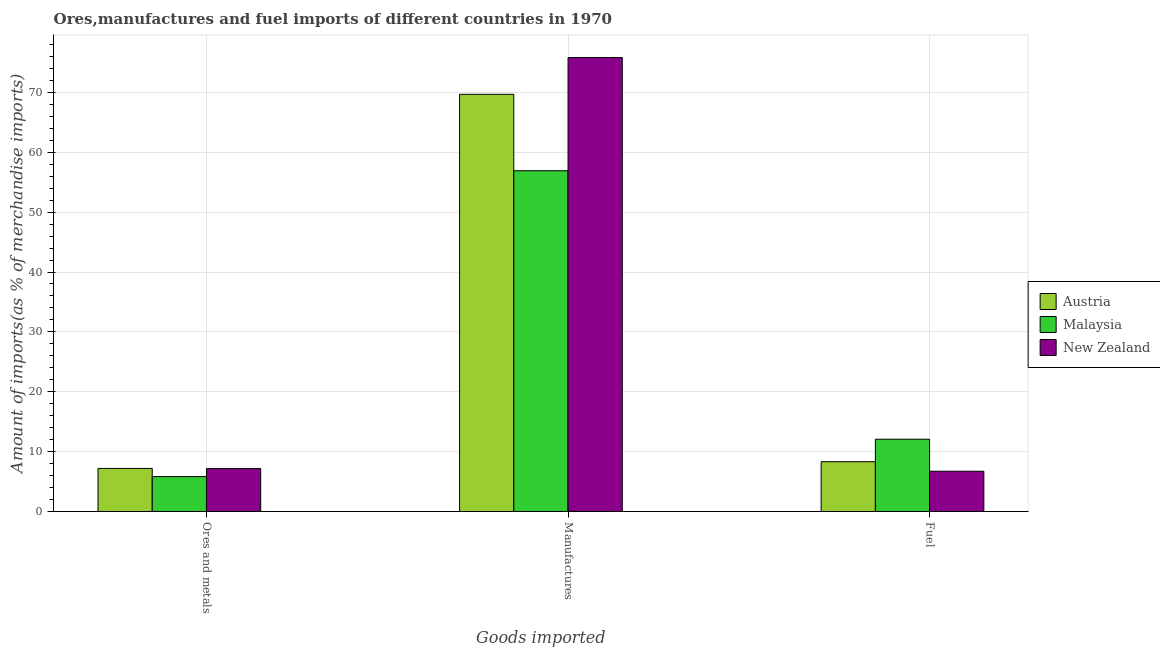How many groups of bars are there?
Give a very brief answer. 3. Are the number of bars per tick equal to the number of legend labels?
Your answer should be very brief. Yes. Are the number of bars on each tick of the X-axis equal?
Provide a short and direct response. Yes. How many bars are there on the 3rd tick from the left?
Offer a terse response. 3. What is the label of the 2nd group of bars from the left?
Offer a terse response. Manufactures. What is the percentage of fuel imports in New Zealand?
Your answer should be compact. 6.72. Across all countries, what is the maximum percentage of fuel imports?
Offer a very short reply. 12.07. Across all countries, what is the minimum percentage of fuel imports?
Keep it short and to the point. 6.72. In which country was the percentage of ores and metals imports maximum?
Offer a very short reply. Austria. In which country was the percentage of fuel imports minimum?
Offer a very short reply. New Zealand. What is the total percentage of ores and metals imports in the graph?
Your response must be concise. 20.19. What is the difference between the percentage of manufactures imports in Malaysia and that in New Zealand?
Make the answer very short. -18.9. What is the difference between the percentage of ores and metals imports in Malaysia and the percentage of manufactures imports in Austria?
Make the answer very short. -63.86. What is the average percentage of ores and metals imports per country?
Provide a short and direct response. 6.73. What is the difference between the percentage of fuel imports and percentage of manufactures imports in Austria?
Keep it short and to the point. -61.37. In how many countries, is the percentage of ores and metals imports greater than 56 %?
Your response must be concise. 0. What is the ratio of the percentage of manufactures imports in Austria to that in Malaysia?
Offer a terse response. 1.22. Is the percentage of ores and metals imports in New Zealand less than that in Malaysia?
Make the answer very short. No. What is the difference between the highest and the second highest percentage of fuel imports?
Your answer should be compact. 3.76. What is the difference between the highest and the lowest percentage of fuel imports?
Keep it short and to the point. 5.34. In how many countries, is the percentage of manufactures imports greater than the average percentage of manufactures imports taken over all countries?
Your answer should be compact. 2. Is the sum of the percentage of fuel imports in Malaysia and Austria greater than the maximum percentage of ores and metals imports across all countries?
Provide a short and direct response. Yes. What does the 2nd bar from the left in Manufactures represents?
Provide a succinct answer. Malaysia. How many bars are there?
Provide a short and direct response. 9. What is the difference between two consecutive major ticks on the Y-axis?
Provide a succinct answer. 10. Does the graph contain grids?
Keep it short and to the point. Yes. How many legend labels are there?
Offer a terse response. 3. How are the legend labels stacked?
Your answer should be compact. Vertical. What is the title of the graph?
Give a very brief answer. Ores,manufactures and fuel imports of different countries in 1970. Does "Jordan" appear as one of the legend labels in the graph?
Give a very brief answer. No. What is the label or title of the X-axis?
Provide a short and direct response. Goods imported. What is the label or title of the Y-axis?
Your answer should be compact. Amount of imports(as % of merchandise imports). What is the Amount of imports(as % of merchandise imports) in Austria in Ores and metals?
Provide a short and direct response. 7.19. What is the Amount of imports(as % of merchandise imports) of Malaysia in Ores and metals?
Make the answer very short. 5.83. What is the Amount of imports(as % of merchandise imports) of New Zealand in Ores and metals?
Ensure brevity in your answer.  7.17. What is the Amount of imports(as % of merchandise imports) of Austria in Manufactures?
Keep it short and to the point. 69.68. What is the Amount of imports(as % of merchandise imports) of Malaysia in Manufactures?
Provide a short and direct response. 56.92. What is the Amount of imports(as % of merchandise imports) of New Zealand in Manufactures?
Give a very brief answer. 75.82. What is the Amount of imports(as % of merchandise imports) in Austria in Fuel?
Provide a short and direct response. 8.31. What is the Amount of imports(as % of merchandise imports) in Malaysia in Fuel?
Your answer should be very brief. 12.07. What is the Amount of imports(as % of merchandise imports) of New Zealand in Fuel?
Provide a succinct answer. 6.72. Across all Goods imported, what is the maximum Amount of imports(as % of merchandise imports) in Austria?
Provide a succinct answer. 69.68. Across all Goods imported, what is the maximum Amount of imports(as % of merchandise imports) in Malaysia?
Your response must be concise. 56.92. Across all Goods imported, what is the maximum Amount of imports(as % of merchandise imports) of New Zealand?
Provide a short and direct response. 75.82. Across all Goods imported, what is the minimum Amount of imports(as % of merchandise imports) in Austria?
Give a very brief answer. 7.19. Across all Goods imported, what is the minimum Amount of imports(as % of merchandise imports) of Malaysia?
Ensure brevity in your answer.  5.83. Across all Goods imported, what is the minimum Amount of imports(as % of merchandise imports) of New Zealand?
Your answer should be very brief. 6.72. What is the total Amount of imports(as % of merchandise imports) of Austria in the graph?
Provide a succinct answer. 85.19. What is the total Amount of imports(as % of merchandise imports) in Malaysia in the graph?
Your response must be concise. 74.81. What is the total Amount of imports(as % of merchandise imports) in New Zealand in the graph?
Provide a succinct answer. 89.72. What is the difference between the Amount of imports(as % of merchandise imports) of Austria in Ores and metals and that in Manufactures?
Offer a terse response. -62.49. What is the difference between the Amount of imports(as % of merchandise imports) of Malaysia in Ores and metals and that in Manufactures?
Offer a very short reply. -51.09. What is the difference between the Amount of imports(as % of merchandise imports) in New Zealand in Ores and metals and that in Manufactures?
Make the answer very short. -68.65. What is the difference between the Amount of imports(as % of merchandise imports) in Austria in Ores and metals and that in Fuel?
Give a very brief answer. -1.12. What is the difference between the Amount of imports(as % of merchandise imports) in Malaysia in Ores and metals and that in Fuel?
Give a very brief answer. -6.24. What is the difference between the Amount of imports(as % of merchandise imports) in New Zealand in Ores and metals and that in Fuel?
Your answer should be compact. 0.45. What is the difference between the Amount of imports(as % of merchandise imports) in Austria in Manufactures and that in Fuel?
Provide a short and direct response. 61.37. What is the difference between the Amount of imports(as % of merchandise imports) of Malaysia in Manufactures and that in Fuel?
Your response must be concise. 44.85. What is the difference between the Amount of imports(as % of merchandise imports) in New Zealand in Manufactures and that in Fuel?
Provide a succinct answer. 69.1. What is the difference between the Amount of imports(as % of merchandise imports) in Austria in Ores and metals and the Amount of imports(as % of merchandise imports) in Malaysia in Manufactures?
Your answer should be compact. -49.73. What is the difference between the Amount of imports(as % of merchandise imports) of Austria in Ores and metals and the Amount of imports(as % of merchandise imports) of New Zealand in Manufactures?
Keep it short and to the point. -68.63. What is the difference between the Amount of imports(as % of merchandise imports) of Malaysia in Ores and metals and the Amount of imports(as % of merchandise imports) of New Zealand in Manufactures?
Provide a succinct answer. -70. What is the difference between the Amount of imports(as % of merchandise imports) in Austria in Ores and metals and the Amount of imports(as % of merchandise imports) in Malaysia in Fuel?
Your answer should be compact. -4.88. What is the difference between the Amount of imports(as % of merchandise imports) in Austria in Ores and metals and the Amount of imports(as % of merchandise imports) in New Zealand in Fuel?
Give a very brief answer. 0.47. What is the difference between the Amount of imports(as % of merchandise imports) of Malaysia in Ores and metals and the Amount of imports(as % of merchandise imports) of New Zealand in Fuel?
Your answer should be compact. -0.9. What is the difference between the Amount of imports(as % of merchandise imports) of Austria in Manufactures and the Amount of imports(as % of merchandise imports) of Malaysia in Fuel?
Your answer should be very brief. 57.62. What is the difference between the Amount of imports(as % of merchandise imports) in Austria in Manufactures and the Amount of imports(as % of merchandise imports) in New Zealand in Fuel?
Your response must be concise. 62.96. What is the difference between the Amount of imports(as % of merchandise imports) of Malaysia in Manufactures and the Amount of imports(as % of merchandise imports) of New Zealand in Fuel?
Ensure brevity in your answer.  50.19. What is the average Amount of imports(as % of merchandise imports) in Austria per Goods imported?
Your answer should be very brief. 28.4. What is the average Amount of imports(as % of merchandise imports) in Malaysia per Goods imported?
Ensure brevity in your answer.  24.94. What is the average Amount of imports(as % of merchandise imports) of New Zealand per Goods imported?
Offer a terse response. 29.91. What is the difference between the Amount of imports(as % of merchandise imports) in Austria and Amount of imports(as % of merchandise imports) in Malaysia in Ores and metals?
Provide a succinct answer. 1.36. What is the difference between the Amount of imports(as % of merchandise imports) in Austria and Amount of imports(as % of merchandise imports) in New Zealand in Ores and metals?
Your answer should be very brief. 0.02. What is the difference between the Amount of imports(as % of merchandise imports) of Malaysia and Amount of imports(as % of merchandise imports) of New Zealand in Ores and metals?
Ensure brevity in your answer.  -1.35. What is the difference between the Amount of imports(as % of merchandise imports) of Austria and Amount of imports(as % of merchandise imports) of Malaysia in Manufactures?
Provide a succinct answer. 12.77. What is the difference between the Amount of imports(as % of merchandise imports) in Austria and Amount of imports(as % of merchandise imports) in New Zealand in Manufactures?
Make the answer very short. -6.14. What is the difference between the Amount of imports(as % of merchandise imports) in Malaysia and Amount of imports(as % of merchandise imports) in New Zealand in Manufactures?
Offer a terse response. -18.9. What is the difference between the Amount of imports(as % of merchandise imports) of Austria and Amount of imports(as % of merchandise imports) of Malaysia in Fuel?
Offer a terse response. -3.76. What is the difference between the Amount of imports(as % of merchandise imports) in Austria and Amount of imports(as % of merchandise imports) in New Zealand in Fuel?
Your answer should be compact. 1.59. What is the difference between the Amount of imports(as % of merchandise imports) of Malaysia and Amount of imports(as % of merchandise imports) of New Zealand in Fuel?
Your answer should be very brief. 5.34. What is the ratio of the Amount of imports(as % of merchandise imports) of Austria in Ores and metals to that in Manufactures?
Keep it short and to the point. 0.1. What is the ratio of the Amount of imports(as % of merchandise imports) of Malaysia in Ores and metals to that in Manufactures?
Provide a short and direct response. 0.1. What is the ratio of the Amount of imports(as % of merchandise imports) of New Zealand in Ores and metals to that in Manufactures?
Offer a terse response. 0.09. What is the ratio of the Amount of imports(as % of merchandise imports) in Austria in Ores and metals to that in Fuel?
Offer a terse response. 0.86. What is the ratio of the Amount of imports(as % of merchandise imports) of Malaysia in Ores and metals to that in Fuel?
Offer a terse response. 0.48. What is the ratio of the Amount of imports(as % of merchandise imports) in New Zealand in Ores and metals to that in Fuel?
Your response must be concise. 1.07. What is the ratio of the Amount of imports(as % of merchandise imports) of Austria in Manufactures to that in Fuel?
Keep it short and to the point. 8.38. What is the ratio of the Amount of imports(as % of merchandise imports) in Malaysia in Manufactures to that in Fuel?
Give a very brief answer. 4.72. What is the ratio of the Amount of imports(as % of merchandise imports) of New Zealand in Manufactures to that in Fuel?
Offer a terse response. 11.28. What is the difference between the highest and the second highest Amount of imports(as % of merchandise imports) of Austria?
Make the answer very short. 61.37. What is the difference between the highest and the second highest Amount of imports(as % of merchandise imports) of Malaysia?
Your response must be concise. 44.85. What is the difference between the highest and the second highest Amount of imports(as % of merchandise imports) in New Zealand?
Provide a short and direct response. 68.65. What is the difference between the highest and the lowest Amount of imports(as % of merchandise imports) of Austria?
Provide a succinct answer. 62.49. What is the difference between the highest and the lowest Amount of imports(as % of merchandise imports) of Malaysia?
Provide a short and direct response. 51.09. What is the difference between the highest and the lowest Amount of imports(as % of merchandise imports) in New Zealand?
Ensure brevity in your answer.  69.1. 